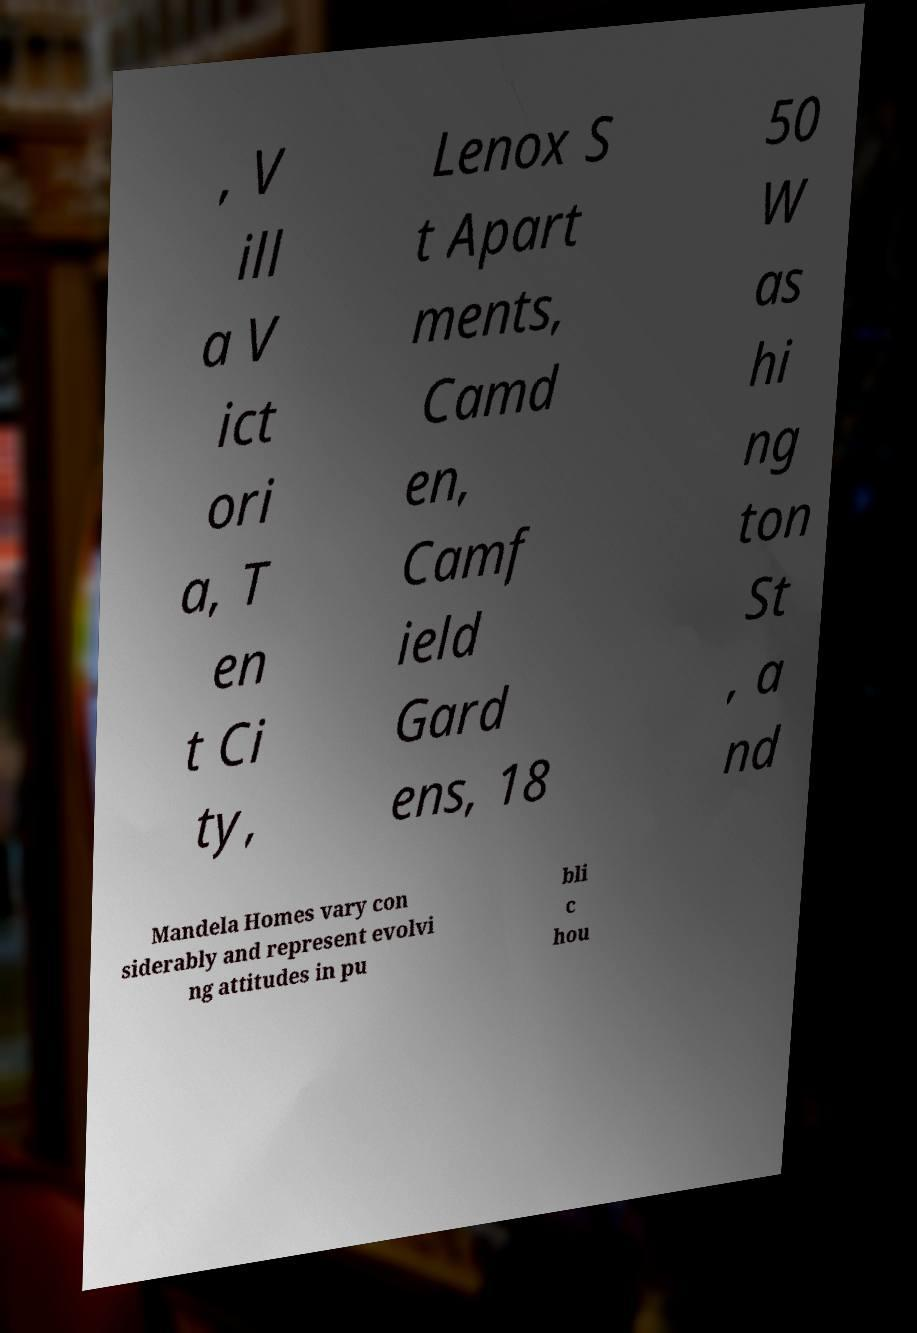Please read and relay the text visible in this image. What does it say? , V ill a V ict ori a, T en t Ci ty, Lenox S t Apart ments, Camd en, Camf ield Gard ens, 18 50 W as hi ng ton St , a nd Mandela Homes vary con siderably and represent evolvi ng attitudes in pu bli c hou 